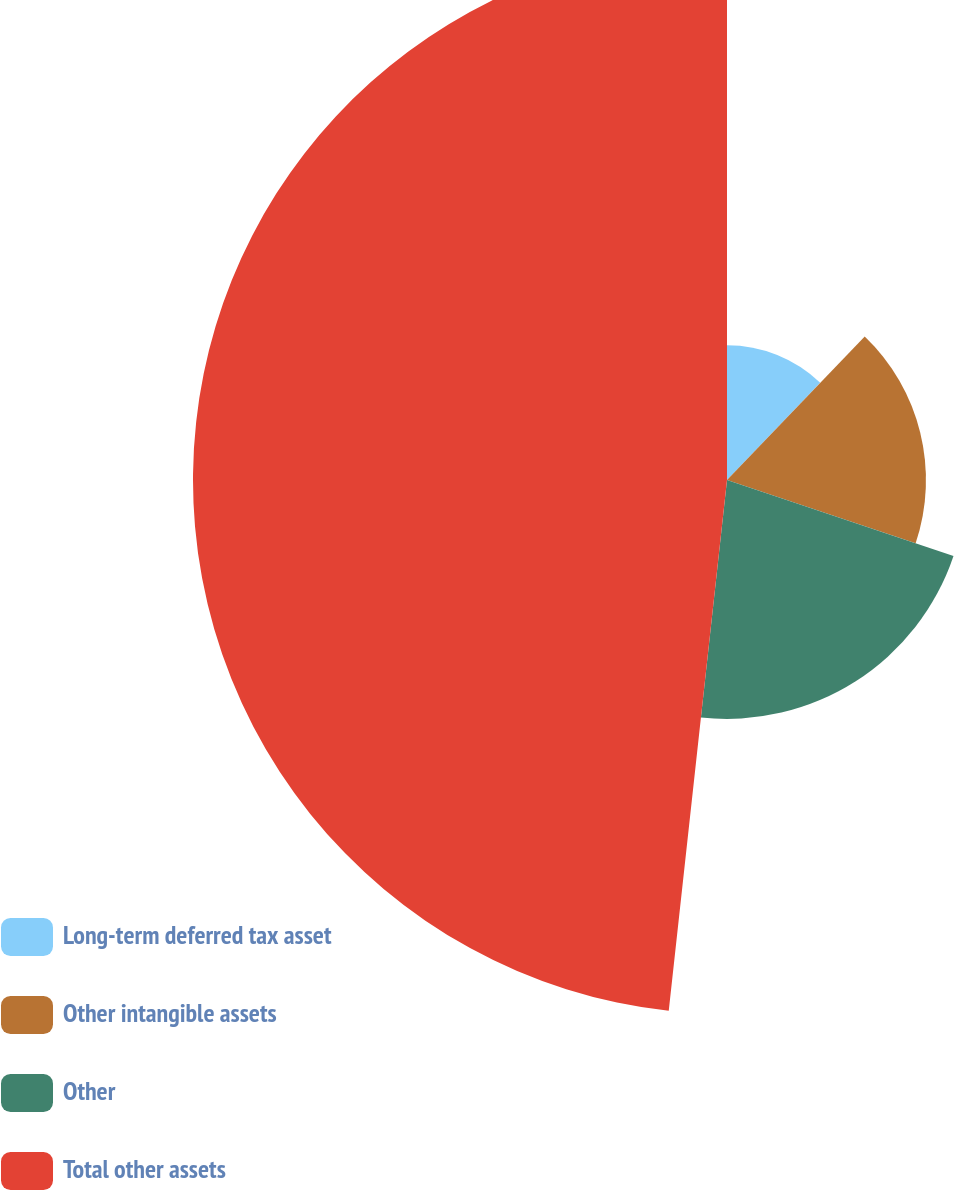<chart> <loc_0><loc_0><loc_500><loc_500><pie_chart><fcel>Long-term deferred tax asset<fcel>Other intangible assets<fcel>Other<fcel>Total other assets<nl><fcel>12.17%<fcel>17.98%<fcel>21.59%<fcel>48.26%<nl></chart> 